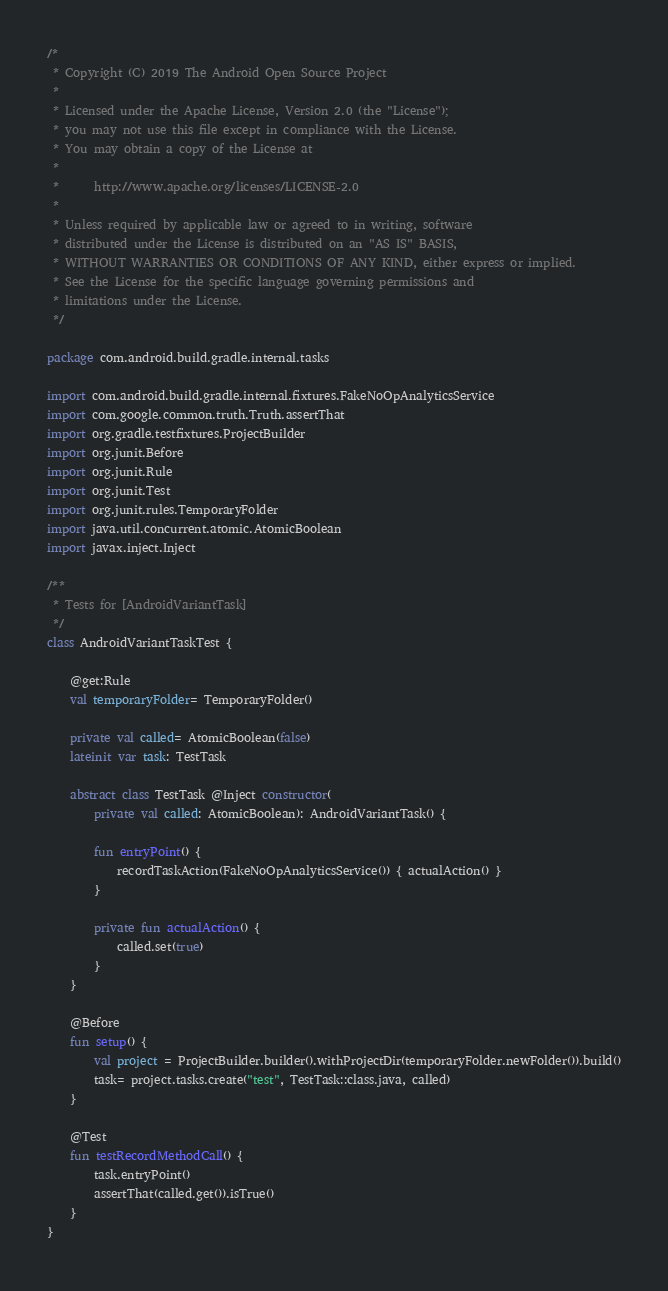Convert code to text. <code><loc_0><loc_0><loc_500><loc_500><_Kotlin_>/*
 * Copyright (C) 2019 The Android Open Source Project
 *
 * Licensed under the Apache License, Version 2.0 (the "License");
 * you may not use this file except in compliance with the License.
 * You may obtain a copy of the License at
 *
 *      http://www.apache.org/licenses/LICENSE-2.0
 *
 * Unless required by applicable law or agreed to in writing, software
 * distributed under the License is distributed on an "AS IS" BASIS,
 * WITHOUT WARRANTIES OR CONDITIONS OF ANY KIND, either express or implied.
 * See the License for the specific language governing permissions and
 * limitations under the License.
 */

package com.android.build.gradle.internal.tasks

import com.android.build.gradle.internal.fixtures.FakeNoOpAnalyticsService
import com.google.common.truth.Truth.assertThat
import org.gradle.testfixtures.ProjectBuilder
import org.junit.Before
import org.junit.Rule
import org.junit.Test
import org.junit.rules.TemporaryFolder
import java.util.concurrent.atomic.AtomicBoolean
import javax.inject.Inject

/**
 * Tests for [AndroidVariantTask]
 */
class AndroidVariantTaskTest {

    @get:Rule
    val temporaryFolder= TemporaryFolder()

    private val called= AtomicBoolean(false)
    lateinit var task: TestTask

    abstract class TestTask @Inject constructor(
        private val called: AtomicBoolean): AndroidVariantTask() {

        fun entryPoint() {
            recordTaskAction(FakeNoOpAnalyticsService()) { actualAction() }
        }

        private fun actualAction() {
            called.set(true)
        }
    }

    @Before
    fun setup() {
        val project = ProjectBuilder.builder().withProjectDir(temporaryFolder.newFolder()).build()
        task= project.tasks.create("test", TestTask::class.java, called)
    }

    @Test
    fun testRecordMethodCall() {
        task.entryPoint()
        assertThat(called.get()).isTrue()
    }
}</code> 